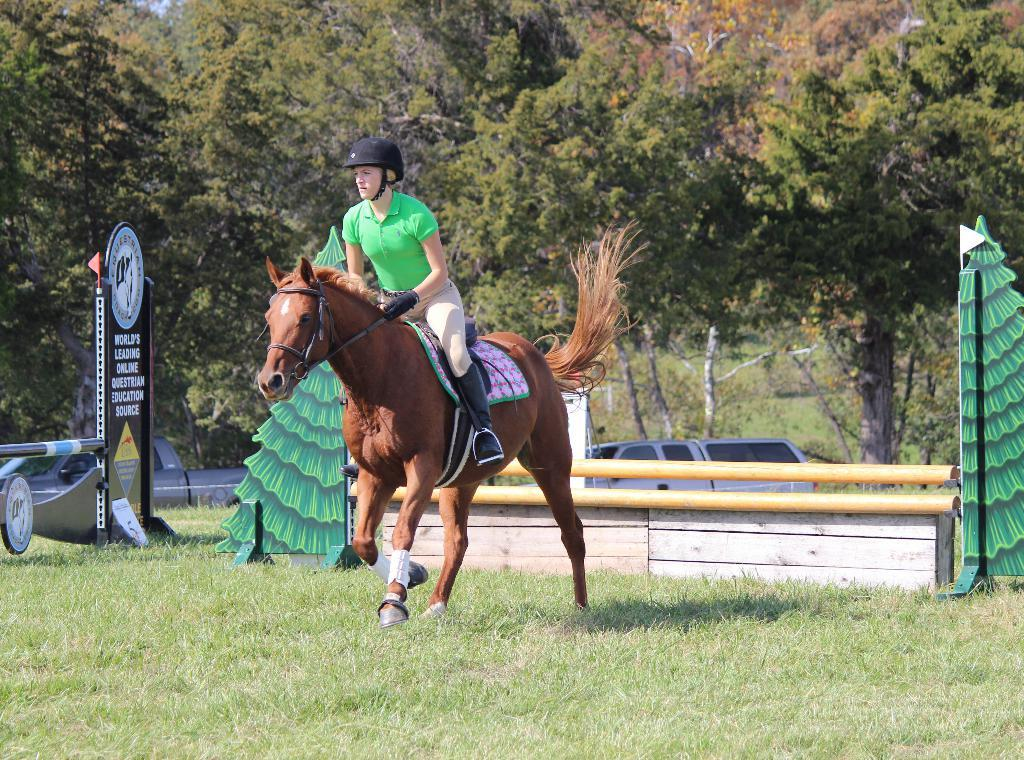What is the person in the image wearing? The person in the image is wearing a green t-shirt. What is the person doing in the image? The person is riding a horse. Where is the horse located in the image? The horse is on the grass. What can be seen in the background of the image? There are hoardings, poles, a vehicle, trees, and grass in the background of the image. What type of iron is being used by the person in the image? There is no iron present in the image; the person is riding a horse. What instrument is the person playing in the image? There is no instrument present in the image; the person is riding a horse. 